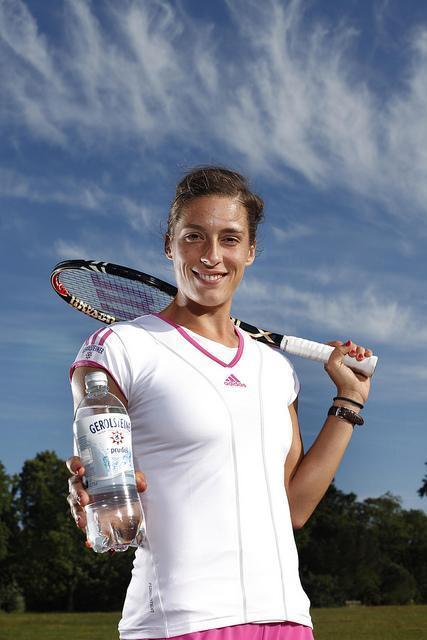How many boats are docked at this pier?
Give a very brief answer. 0. 